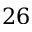Convert formula to latex. <formula><loc_0><loc_0><loc_500><loc_500>2 6</formula> 